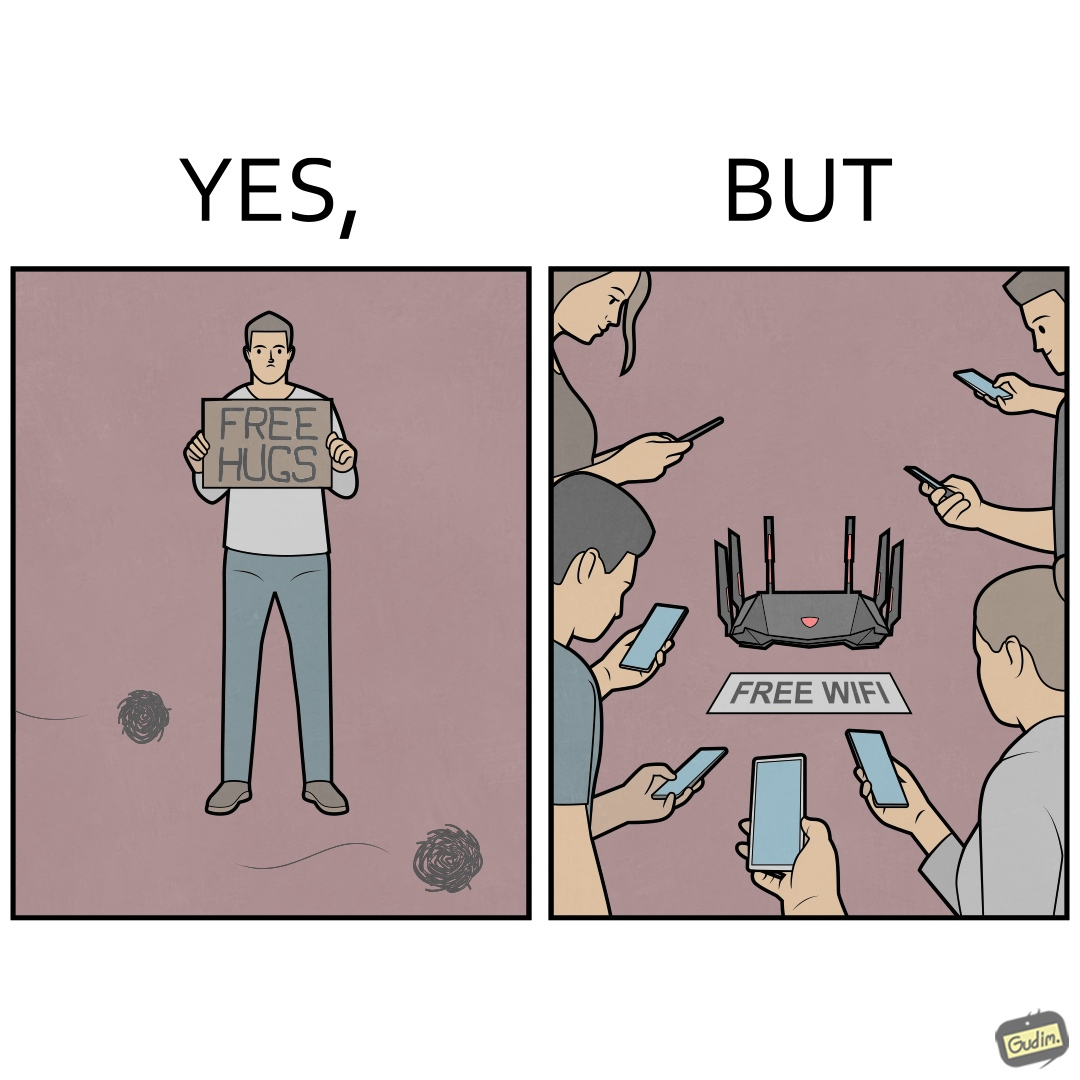Describe the content of this image. This image is ironical, as a person holding up a "Free Hugs" sign is standing alone, while an inanimate Wi-fi Router giving "Free Wifi" is surrounded people trying to connect to it. This shows a growing lack of empathy in our society, while showing our increasing dependence on the digital devices in a virtual world. 